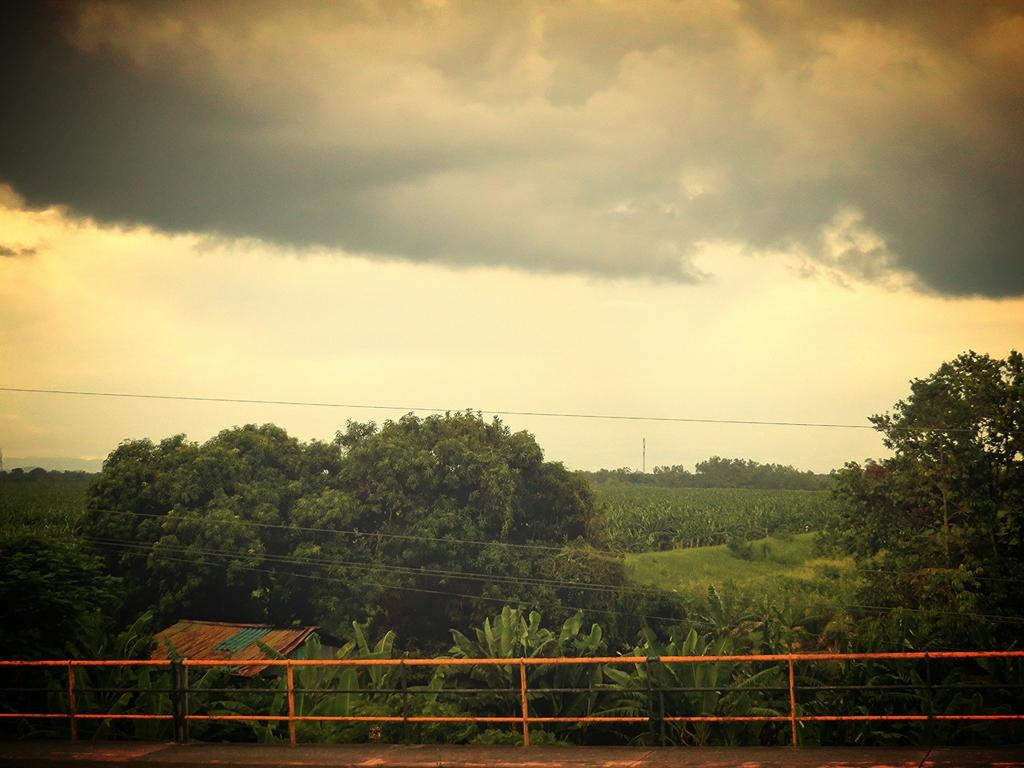What is the main feature that stretches from left to right in the image? There is a fence in the image, stretching from left to right. What type of vegetation can be seen in the image? There are a few plants in the image. What structure is visible in the image? There is a house in the image. What is on top of the fence in the image? There is a wire on top of the fence in the image. What can be seen in the background of the image? There are trees visible in the background of the image. How would you describe the sky in the image? The sky is cloudy in the image. What type of toy is being used to commit a crime in the image? There is no toy or crime present in the image. 